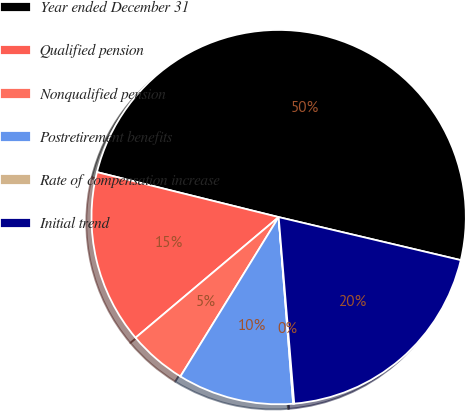Convert chart. <chart><loc_0><loc_0><loc_500><loc_500><pie_chart><fcel>Year ended December 31<fcel>Qualified pension<fcel>Nonqualified pension<fcel>Postretirement benefits<fcel>Rate of compensation increase<fcel>Initial trend<nl><fcel>49.83%<fcel>15.01%<fcel>5.06%<fcel>10.03%<fcel>0.09%<fcel>19.98%<nl></chart> 